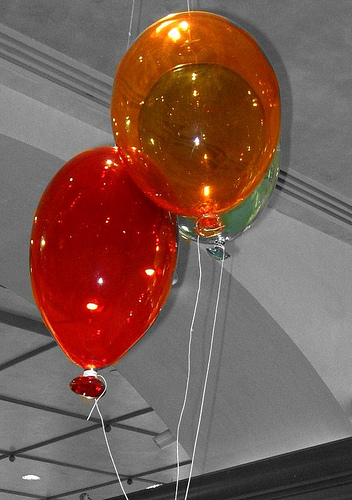<image>
Is there a balloon in the ceiling? No. The balloon is not contained within the ceiling. These objects have a different spatial relationship. 